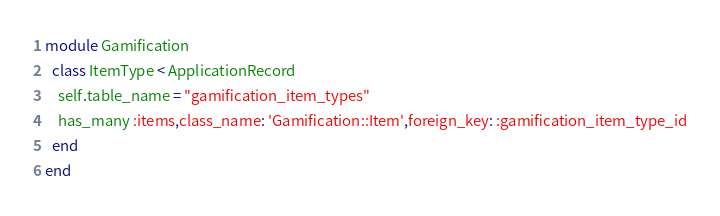Convert code to text. <code><loc_0><loc_0><loc_500><loc_500><_Ruby_>module Gamification
  class ItemType < ApplicationRecord
    self.table_name = "gamification_item_types"
    has_many :items,class_name: 'Gamification::Item',foreign_key: :gamification_item_type_id
  end
end
</code> 